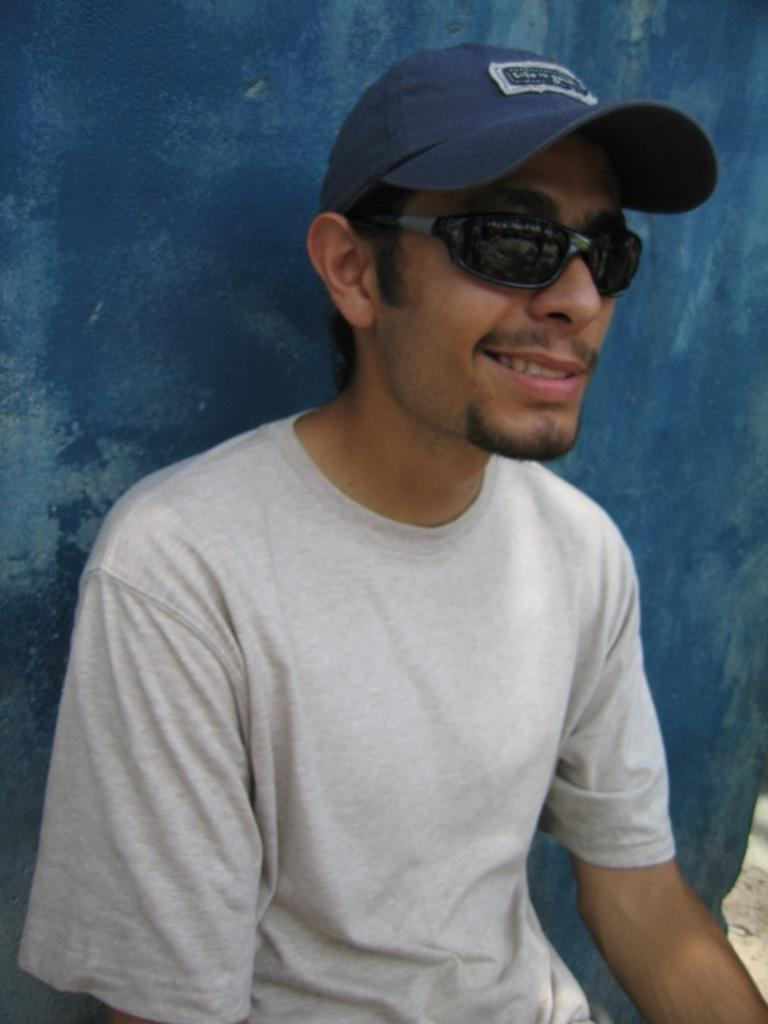Who is present in the image? There is a man in the picture. What is the man wearing on his head? The man is wearing a cap. What type of shirt is the man wearing? The man is wearing a t-shirt. What is the man wearing to protect his eyes? The man is wearing goggles. What color is the wall behind the man? The wall behind the man is blue. What is the man's facial expression? The man is smiling. How many children are playing on the grass in the image? There are no children or grass present in the image; it features a man wearing a cap, t-shirt, and goggles while sitting near a blue wall. 